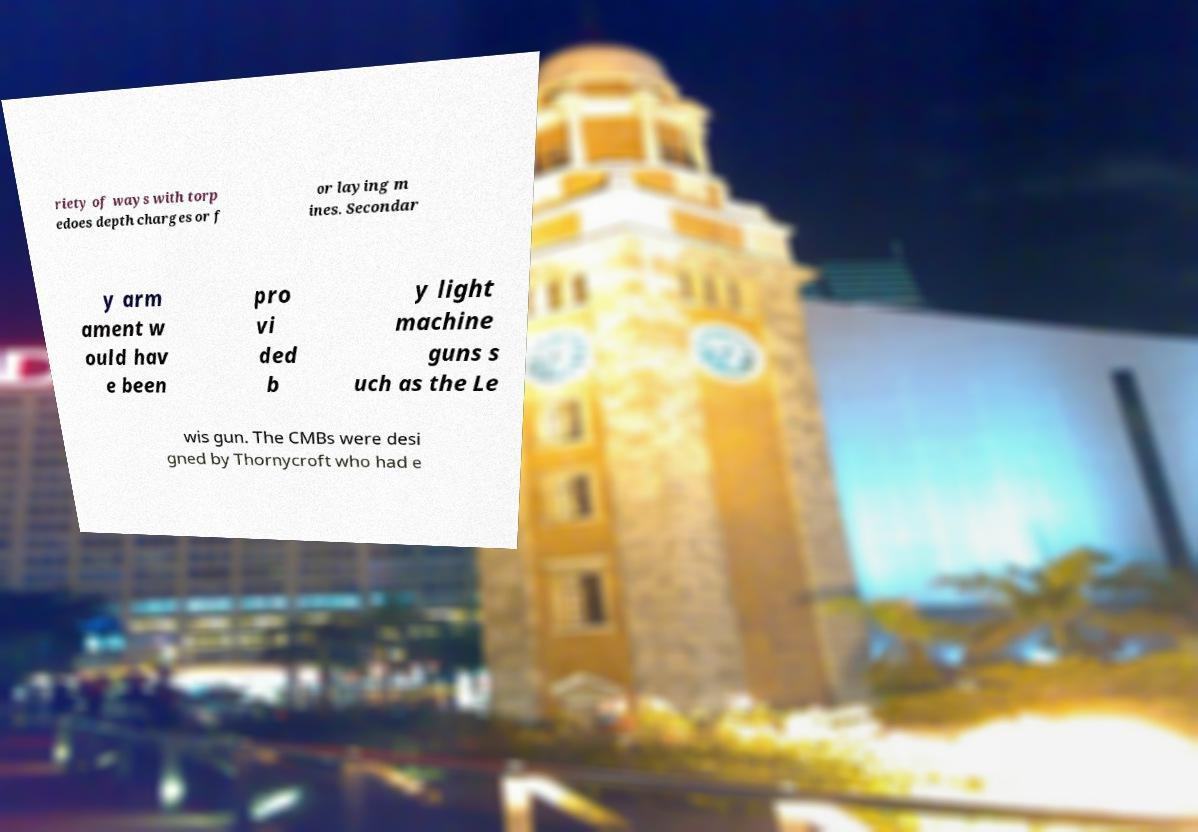Please identify and transcribe the text found in this image. riety of ways with torp edoes depth charges or f or laying m ines. Secondar y arm ament w ould hav e been pro vi ded b y light machine guns s uch as the Le wis gun. The CMBs were desi gned by Thornycroft who had e 